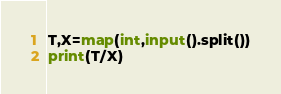<code> <loc_0><loc_0><loc_500><loc_500><_Python_>T,X=map(int,input().split())
print(T/X)</code> 